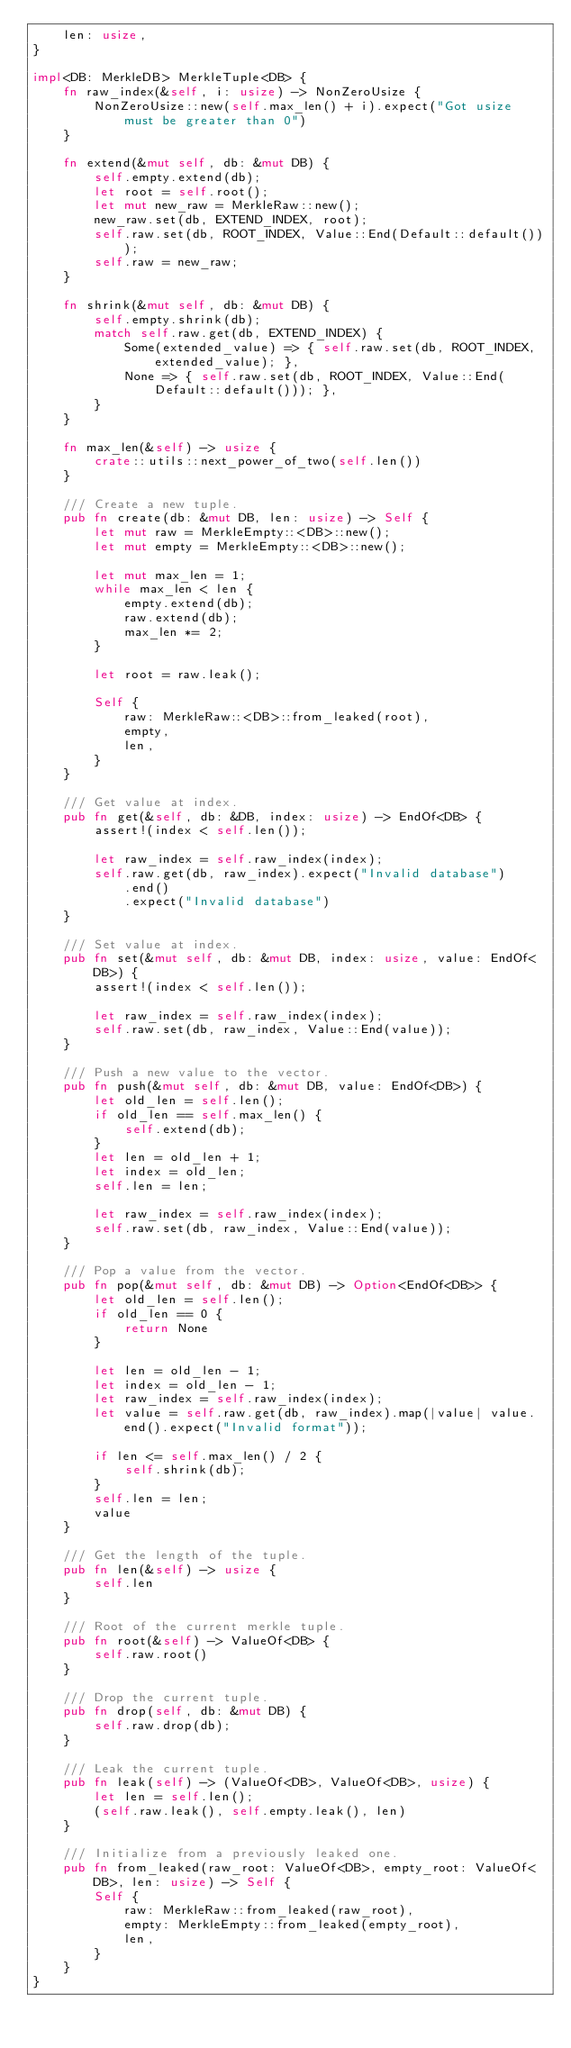<code> <loc_0><loc_0><loc_500><loc_500><_Rust_>    len: usize,
}

impl<DB: MerkleDB> MerkleTuple<DB> {
    fn raw_index(&self, i: usize) -> NonZeroUsize {
        NonZeroUsize::new(self.max_len() + i).expect("Got usize must be greater than 0")
    }

    fn extend(&mut self, db: &mut DB) {
        self.empty.extend(db);
        let root = self.root();
        let mut new_raw = MerkleRaw::new();
        new_raw.set(db, EXTEND_INDEX, root);
        self.raw.set(db, ROOT_INDEX, Value::End(Default::default()));
        self.raw = new_raw;
    }

    fn shrink(&mut self, db: &mut DB) {
        self.empty.shrink(db);
        match self.raw.get(db, EXTEND_INDEX) {
            Some(extended_value) => { self.raw.set(db, ROOT_INDEX, extended_value); },
            None => { self.raw.set(db, ROOT_INDEX, Value::End(Default::default())); },
        }
    }

    fn max_len(&self) -> usize {
        crate::utils::next_power_of_two(self.len())
    }

    /// Create a new tuple.
    pub fn create(db: &mut DB, len: usize) -> Self {
        let mut raw = MerkleEmpty::<DB>::new();
        let mut empty = MerkleEmpty::<DB>::new();

        let mut max_len = 1;
        while max_len < len {
            empty.extend(db);
            raw.extend(db);
            max_len *= 2;
        }

        let root = raw.leak();

        Self {
            raw: MerkleRaw::<DB>::from_leaked(root),
            empty,
            len,
        }
    }

    /// Get value at index.
    pub fn get(&self, db: &DB, index: usize) -> EndOf<DB> {
        assert!(index < self.len());

        let raw_index = self.raw_index(index);
        self.raw.get(db, raw_index).expect("Invalid database")
            .end()
            .expect("Invalid database")
    }

    /// Set value at index.
    pub fn set(&mut self, db: &mut DB, index: usize, value: EndOf<DB>) {
        assert!(index < self.len());

        let raw_index = self.raw_index(index);
        self.raw.set(db, raw_index, Value::End(value));
    }

    /// Push a new value to the vector.
    pub fn push(&mut self, db: &mut DB, value: EndOf<DB>) {
        let old_len = self.len();
        if old_len == self.max_len() {
            self.extend(db);
        }
        let len = old_len + 1;
        let index = old_len;
        self.len = len;

        let raw_index = self.raw_index(index);
        self.raw.set(db, raw_index, Value::End(value));
    }

    /// Pop a value from the vector.
    pub fn pop(&mut self, db: &mut DB) -> Option<EndOf<DB>> {
        let old_len = self.len();
        if old_len == 0 {
            return None
        }

        let len = old_len - 1;
        let index = old_len - 1;
        let raw_index = self.raw_index(index);
        let value = self.raw.get(db, raw_index).map(|value| value.end().expect("Invalid format"));

        if len <= self.max_len() / 2 {
            self.shrink(db);
        }
        self.len = len;
        value
    }

    /// Get the length of the tuple.
    pub fn len(&self) -> usize {
        self.len
    }

    /// Root of the current merkle tuple.
    pub fn root(&self) -> ValueOf<DB> {
        self.raw.root()
    }

    /// Drop the current tuple.
    pub fn drop(self, db: &mut DB) {
        self.raw.drop(db);
    }

    /// Leak the current tuple.
    pub fn leak(self) -> (ValueOf<DB>, ValueOf<DB>, usize) {
        let len = self.len();
        (self.raw.leak(), self.empty.leak(), len)
    }

    /// Initialize from a previously leaked one.
    pub fn from_leaked(raw_root: ValueOf<DB>, empty_root: ValueOf<DB>, len: usize) -> Self {
        Self {
            raw: MerkleRaw::from_leaked(raw_root),
            empty: MerkleEmpty::from_leaked(empty_root),
            len,
        }
    }
}
</code> 